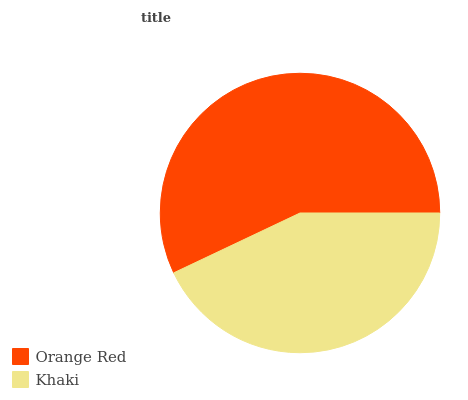Is Khaki the minimum?
Answer yes or no. Yes. Is Orange Red the maximum?
Answer yes or no. Yes. Is Khaki the maximum?
Answer yes or no. No. Is Orange Red greater than Khaki?
Answer yes or no. Yes. Is Khaki less than Orange Red?
Answer yes or no. Yes. Is Khaki greater than Orange Red?
Answer yes or no. No. Is Orange Red less than Khaki?
Answer yes or no. No. Is Orange Red the high median?
Answer yes or no. Yes. Is Khaki the low median?
Answer yes or no. Yes. Is Khaki the high median?
Answer yes or no. No. Is Orange Red the low median?
Answer yes or no. No. 